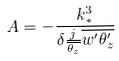<formula> <loc_0><loc_0><loc_500><loc_500>A = - \frac { k _ { * } ^ { 3 } } { \delta \frac { j } { \overline { \theta _ { z } } } \overline { w ^ { \prime } \theta _ { z } ^ { \prime } } }</formula> 